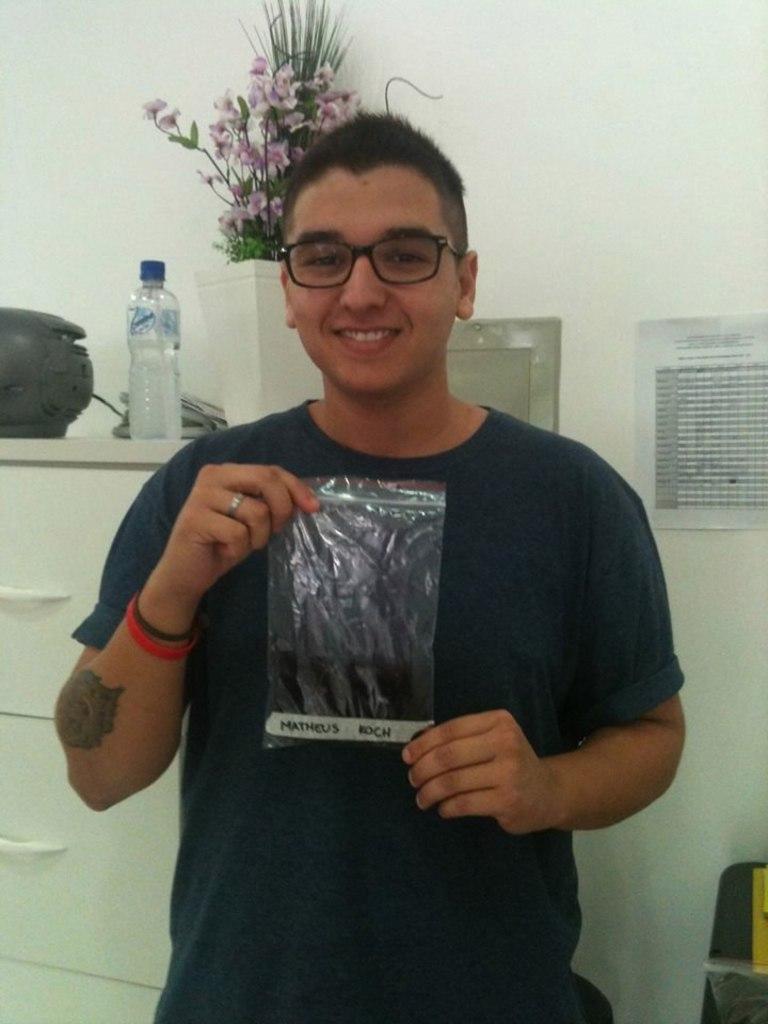In one or two sentences, can you explain what this image depicts? In this image there is one man who is standing and he is holding a plastic cover and he is smiling. On the background there is a wall ,on the left side there is one table on that table there is one glass and one flower pot and one plant is there. 